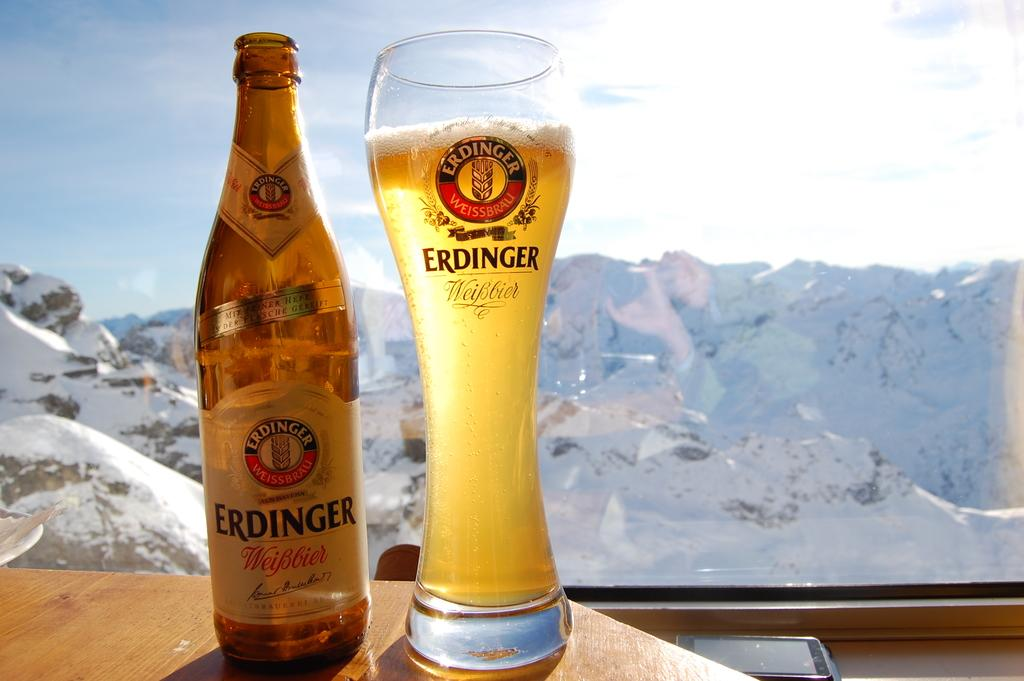<image>
Present a compact description of the photo's key features. Bottle of Erdinger and a glass stands next to it in a window. 